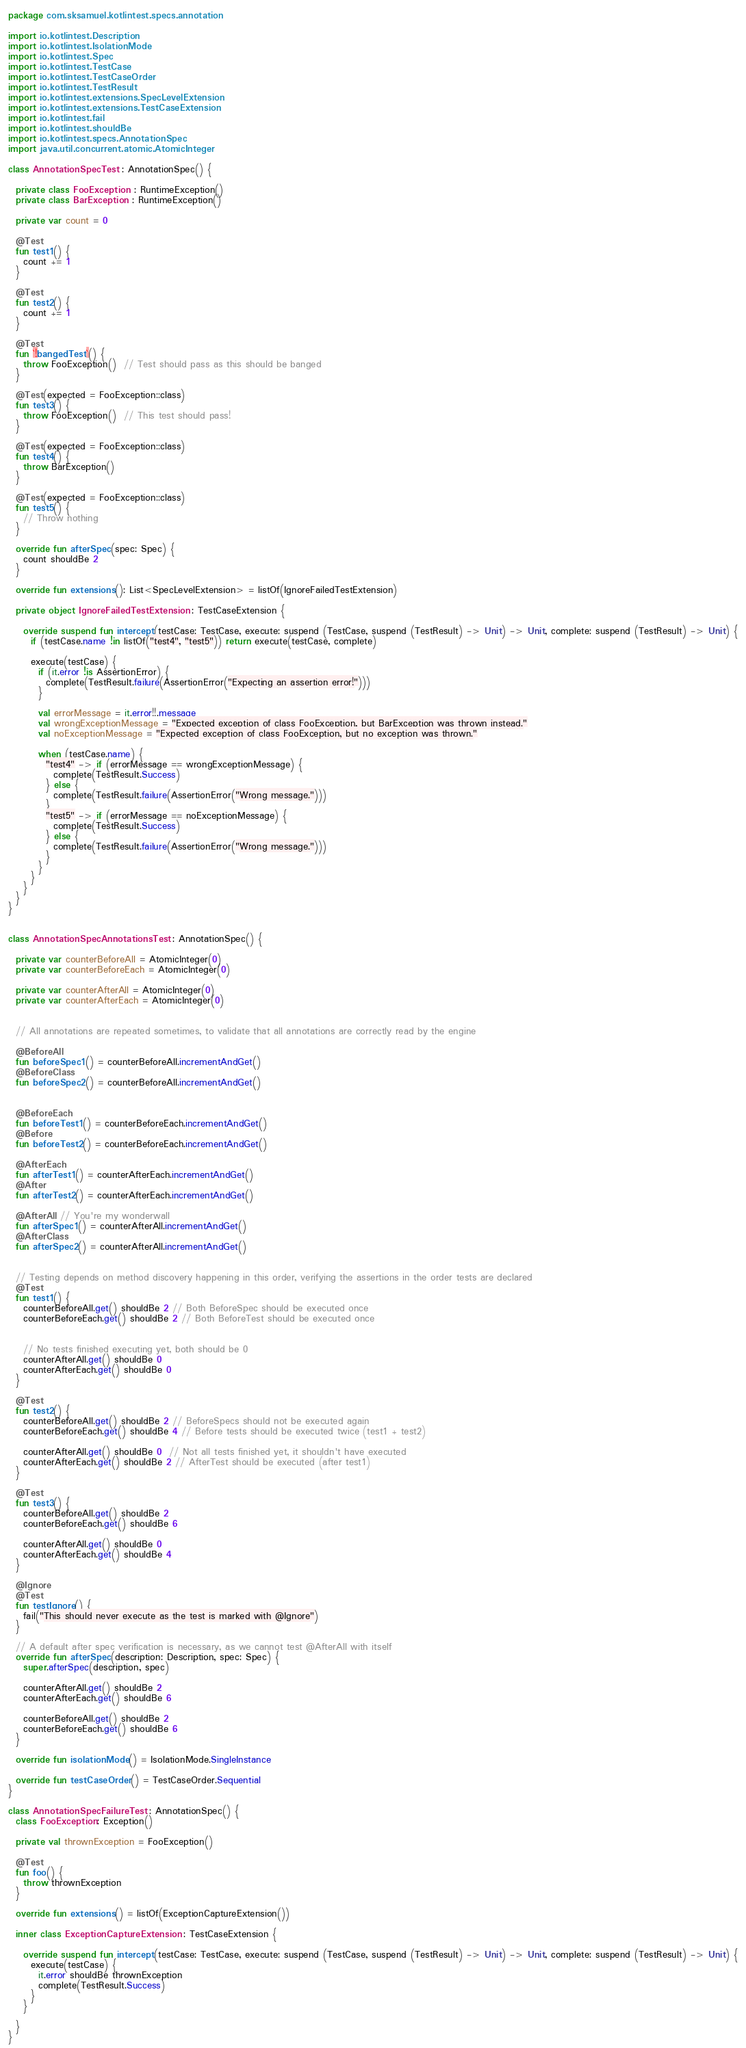<code> <loc_0><loc_0><loc_500><loc_500><_Kotlin_>package com.sksamuel.kotlintest.specs.annotation

import io.kotlintest.Description
import io.kotlintest.IsolationMode
import io.kotlintest.Spec
import io.kotlintest.TestCase
import io.kotlintest.TestCaseOrder
import io.kotlintest.TestResult
import io.kotlintest.extensions.SpecLevelExtension
import io.kotlintest.extensions.TestCaseExtension
import io.kotlintest.fail
import io.kotlintest.shouldBe
import io.kotlintest.specs.AnnotationSpec
import java.util.concurrent.atomic.AtomicInteger

class AnnotationSpecTest : AnnotationSpec() {

  private class FooException : RuntimeException()
  private class BarException : RuntimeException()

  private var count = 0

  @Test
  fun test1() {
    count += 1
  }

  @Test
  fun test2() {
    count += 1
  }

  @Test
  fun `!bangedTest`() {
    throw FooException()  // Test should pass as this should be banged
  }

  @Test(expected = FooException::class)
  fun test3() {
    throw FooException()  // This test should pass!
  }

  @Test(expected = FooException::class)
  fun test4() {
    throw BarException()
  }

  @Test(expected = FooException::class)
  fun test5() {
    // Throw nothing
  }

  override fun afterSpec(spec: Spec) {
    count shouldBe 2
  }

  override fun extensions(): List<SpecLevelExtension> = listOf(IgnoreFailedTestExtension)

  private object IgnoreFailedTestExtension : TestCaseExtension {

    override suspend fun intercept(testCase: TestCase, execute: suspend (TestCase, suspend (TestResult) -> Unit) -> Unit, complete: suspend (TestResult) -> Unit) {
      if (testCase.name !in listOf("test4", "test5")) return execute(testCase, complete)

      execute(testCase) {
        if (it.error !is AssertionError) {
          complete(TestResult.failure(AssertionError("Expecting an assertion error!")))
        }

        val errorMessage = it.error!!.message
        val wrongExceptionMessage = "Expected exception of class FooException, but BarException was thrown instead."
        val noExceptionMessage = "Expected exception of class FooException, but no exception was thrown."

        when (testCase.name) {
          "test4" -> if (errorMessage == wrongExceptionMessage) {
            complete(TestResult.Success)
          } else {
            complete(TestResult.failure(AssertionError("Wrong message.")))
          }
          "test5" -> if (errorMessage == noExceptionMessage) {
            complete(TestResult.Success)
          } else {
            complete(TestResult.failure(AssertionError("Wrong message.")))
          }
        }
      }
    }
  }
}


class AnnotationSpecAnnotationsTest : AnnotationSpec() {

  private var counterBeforeAll = AtomicInteger(0)
  private var counterBeforeEach = AtomicInteger(0)

  private var counterAfterAll = AtomicInteger(0)
  private var counterAfterEach = AtomicInteger(0)


  // All annotations are repeated sometimes, to validate that all annotations are correctly read by the engine

  @BeforeAll
  fun beforeSpec1() = counterBeforeAll.incrementAndGet()
  @BeforeClass
  fun beforeSpec2() = counterBeforeAll.incrementAndGet()


  @BeforeEach
  fun beforeTest1() = counterBeforeEach.incrementAndGet()
  @Before
  fun beforeTest2() = counterBeforeEach.incrementAndGet()

  @AfterEach
  fun afterTest1() = counterAfterEach.incrementAndGet()
  @After
  fun afterTest2() = counterAfterEach.incrementAndGet()

  @AfterAll // You're my wonderwall
  fun afterSpec1() = counterAfterAll.incrementAndGet()
  @AfterClass
  fun afterSpec2() = counterAfterAll.incrementAndGet()


  // Testing depends on method discovery happening in this order, verifying the assertions in the order tests are declared
  @Test
  fun test1() {
    counterBeforeAll.get() shouldBe 2 // Both BeforeSpec should be executed once
    counterBeforeEach.get() shouldBe 2 // Both BeforeTest should be executed once


    // No tests finished executing yet, both should be 0
    counterAfterAll.get() shouldBe 0
    counterAfterEach.get() shouldBe 0
  }

  @Test
  fun test2() {
    counterBeforeAll.get() shouldBe 2 // BeforeSpecs should not be executed again
    counterBeforeEach.get() shouldBe 4 // Before tests should be executed twice (test1 + test2)

    counterAfterAll.get() shouldBe 0  // Not all tests finished yet, it shouldn't have executed
    counterAfterEach.get() shouldBe 2 // AfterTest should be executed (after test1)
  }

  @Test
  fun test3() {
    counterBeforeAll.get() shouldBe 2
    counterBeforeEach.get() shouldBe 6

    counterAfterAll.get() shouldBe 0
    counterAfterEach.get() shouldBe 4
  }

  @Ignore
  @Test
  fun testIgnore() {
    fail("This should never execute as the test is marked with @Ignore")
  }

  // A default after spec verification is necessary, as we cannot test @AfterAll with itself
  override fun afterSpec(description: Description, spec: Spec) {
    super.afterSpec(description, spec)

    counterAfterAll.get() shouldBe 2
    counterAfterEach.get() shouldBe 6

    counterBeforeAll.get() shouldBe 2
    counterBeforeEach.get() shouldBe 6
  }

  override fun isolationMode() = IsolationMode.SingleInstance

  override fun testCaseOrder() = TestCaseOrder.Sequential
}

class AnnotationSpecFailureTest : AnnotationSpec() {
  class FooException: Exception()

  private val thrownException = FooException()

  @Test
  fun foo() {
    throw thrownException
  }

  override fun extensions() = listOf(ExceptionCaptureExtension())

  inner class ExceptionCaptureExtension : TestCaseExtension {

    override suspend fun intercept(testCase: TestCase, execute: suspend (TestCase, suspend (TestResult) -> Unit) -> Unit, complete: suspend (TestResult) -> Unit) {
      execute(testCase) {
        it.error shouldBe thrownException
        complete(TestResult.Success)
      }
    }

  }
}</code> 